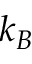Convert formula to latex. <formula><loc_0><loc_0><loc_500><loc_500>k _ { B }</formula> 